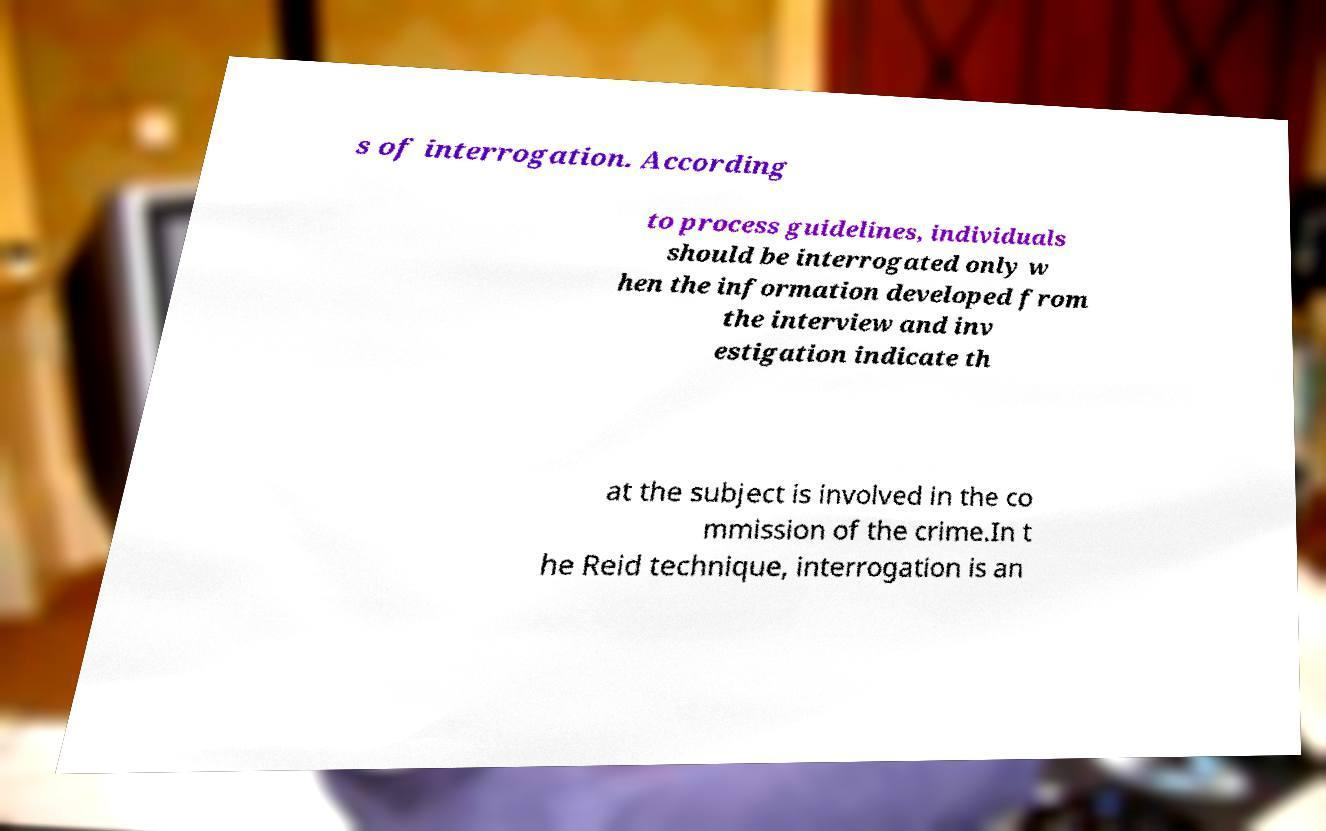Can you accurately transcribe the text from the provided image for me? s of interrogation. According to process guidelines, individuals should be interrogated only w hen the information developed from the interview and inv estigation indicate th at the subject is involved in the co mmission of the crime.In t he Reid technique, interrogation is an 